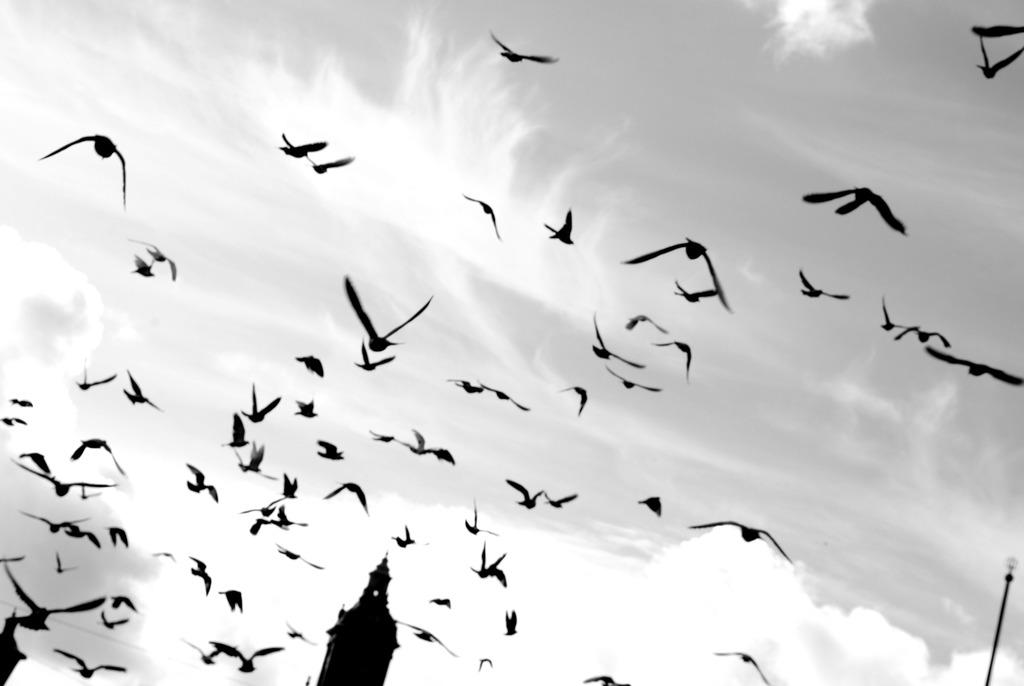What is happening in the sky in the image? There are birds flying in the sky in the image. What type of structure can be seen in the image? There is a temple in the image. What is attached to the pole in the image? There is a light attached to the pole in the image. How many rods are visible in the image? There are no rods present in the image. What type of bottle can be seen near the temple in the image? There is no bottle present in the image. 